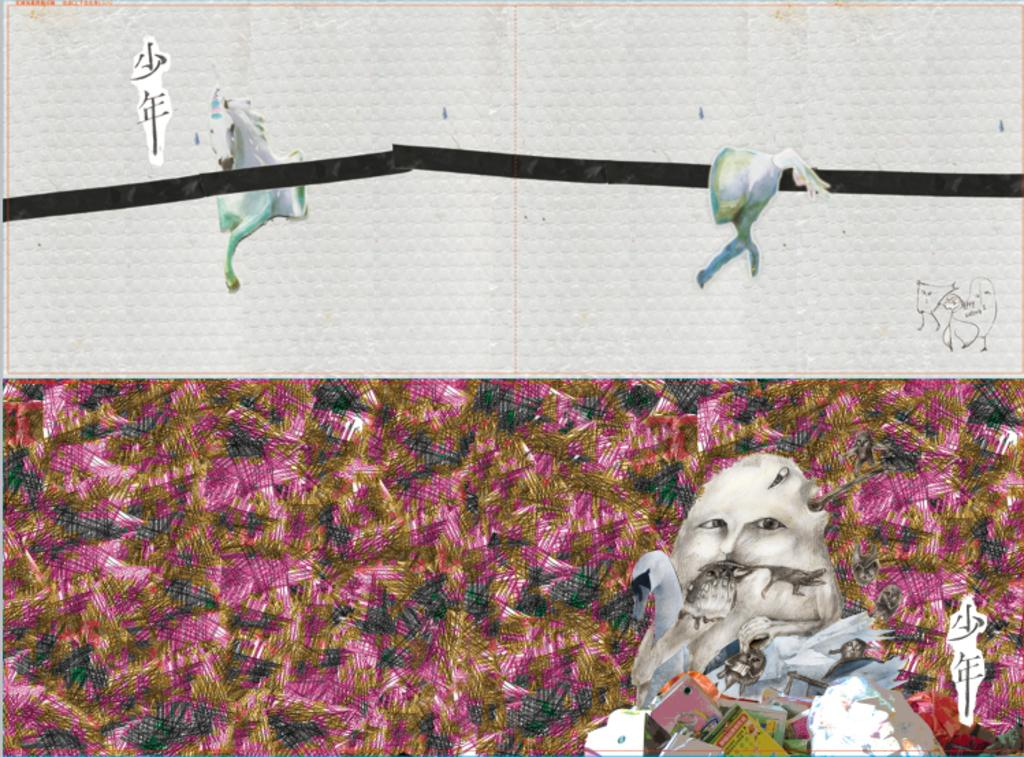What type of image is being described? The image is a poster. What animals are depicted on the poster? There is a picture of a horse and a swan on the poster. Are there any people shown on the poster? Yes, there is a picture of a person on the poster. What other objects are featured on the poster? Books are depicted on the poster. Where is the text located on the poster? The text is at the top left of the poster. What type of marble is used as a background for the poster? There is no mention of marble being used as a background for the poster. The poster features a picture of a horse, a person, books, a swan, and text, but no marble. 